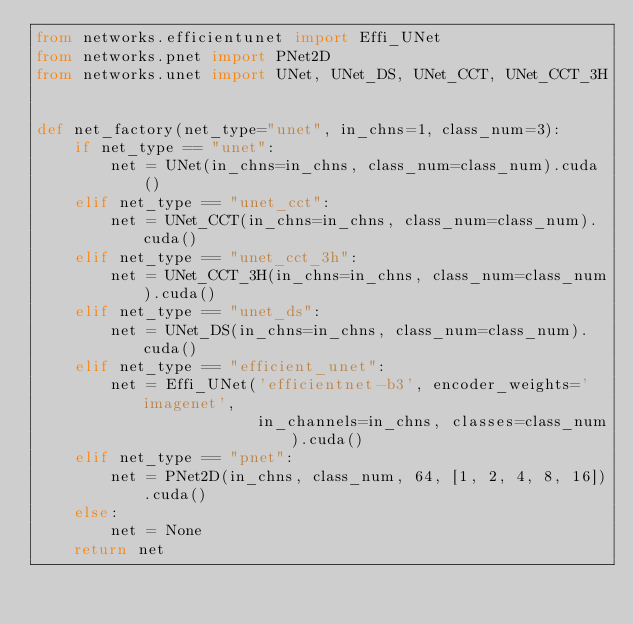Convert code to text. <code><loc_0><loc_0><loc_500><loc_500><_Python_>from networks.efficientunet import Effi_UNet
from networks.pnet import PNet2D
from networks.unet import UNet, UNet_DS, UNet_CCT, UNet_CCT_3H


def net_factory(net_type="unet", in_chns=1, class_num=3):
    if net_type == "unet":
        net = UNet(in_chns=in_chns, class_num=class_num).cuda()
    elif net_type == "unet_cct":
        net = UNet_CCT(in_chns=in_chns, class_num=class_num).cuda()
    elif net_type == "unet_cct_3h":
        net = UNet_CCT_3H(in_chns=in_chns, class_num=class_num).cuda()
    elif net_type == "unet_ds":
        net = UNet_DS(in_chns=in_chns, class_num=class_num).cuda()
    elif net_type == "efficient_unet":
        net = Effi_UNet('efficientnet-b3', encoder_weights='imagenet',
                        in_channels=in_chns, classes=class_num).cuda()
    elif net_type == "pnet":
        net = PNet2D(in_chns, class_num, 64, [1, 2, 4, 8, 16]).cuda()
    else:
        net = None
    return net
</code> 